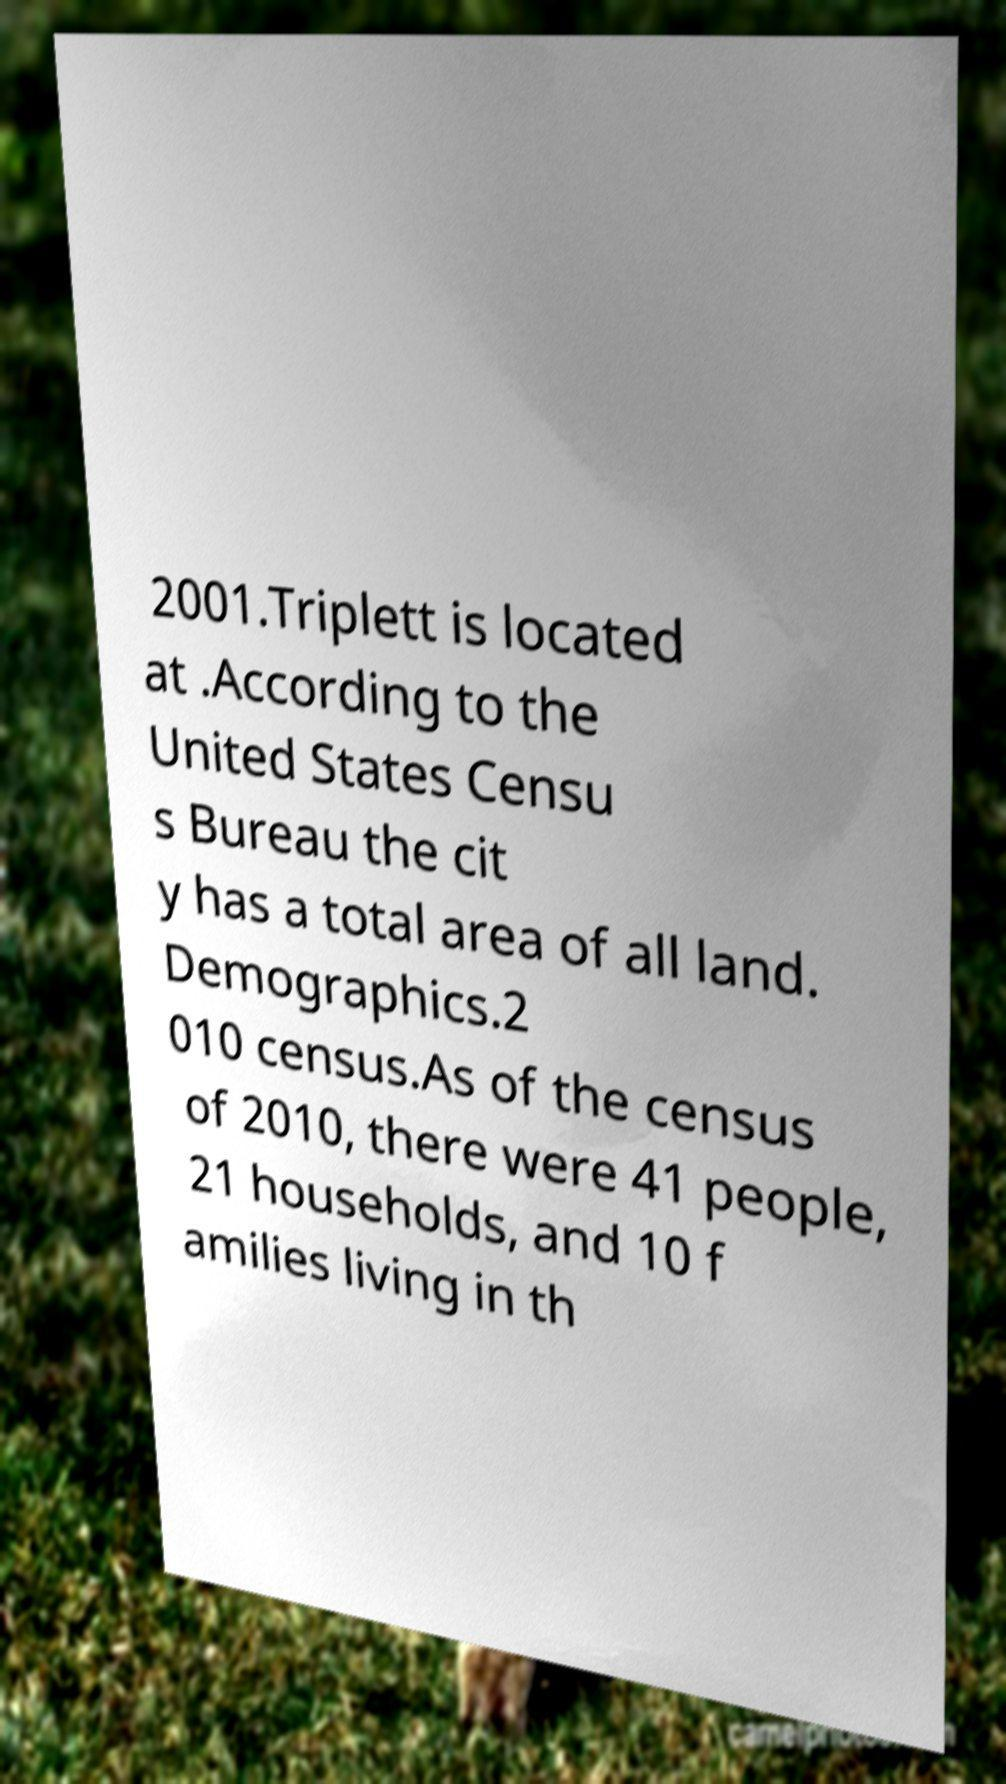Could you extract and type out the text from this image? 2001.Triplett is located at .According to the United States Censu s Bureau the cit y has a total area of all land. Demographics.2 010 census.As of the census of 2010, there were 41 people, 21 households, and 10 f amilies living in th 